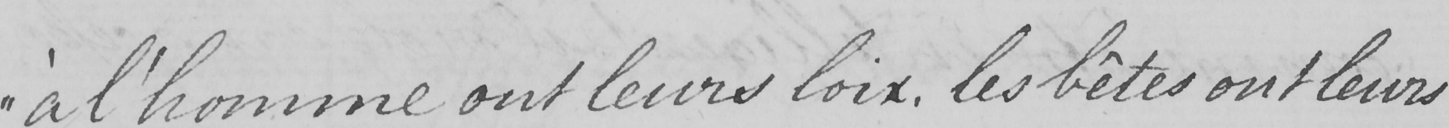Transcribe the text shown in this historical manuscript line. " à l ' homme ont leurs loix , les bêtes ont leurs 